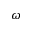Convert formula to latex. <formula><loc_0><loc_0><loc_500><loc_500>\omega</formula> 